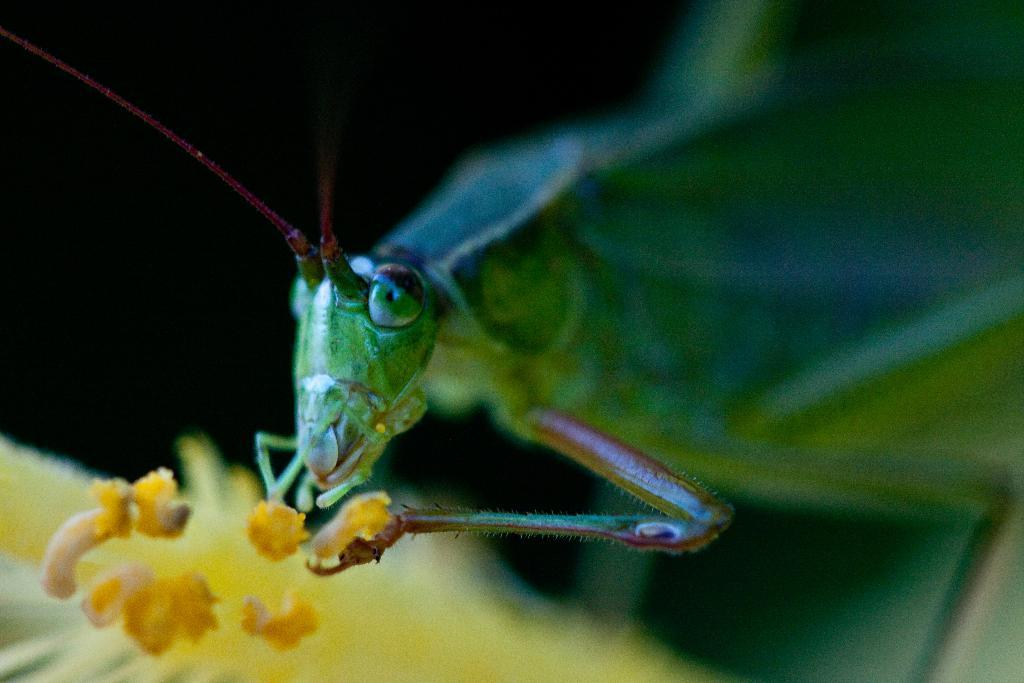What type of creature is present in the image? There is an insect in the image. What color is the insect? The insect is green in color. What other object can be seen in the image? There is a flower in the image. What color is the flower? The flower is yellow in color. What is the background of the image? The background of the image is black. Can you read any letters on the insect in the image? There are no letters present on the insect in the image. Is there any dust visible on the flower in the image? There is no dust visible on the flower in the image. 